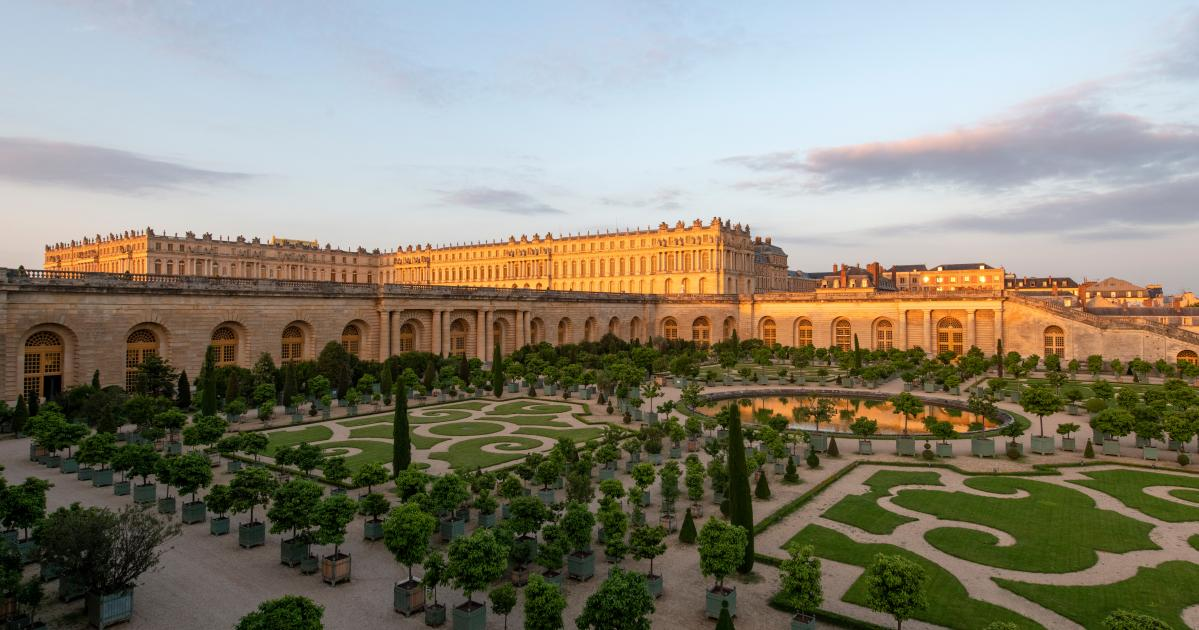How does the presence of the fountain enhance the overall aesthetic of the palace gardens? The fountain is the centerpiece of the palace gardens, enhancing their aesthetic with its dynamic presence. Its cascading waters add a sense of movement and life to the otherwise still and meticulously arranged greenery. The sound of the flowing water provides a calming ambiance, while the reflections of light on the water's surface create a mesmerizing effect. The fountain's ornate design complements the geometric precision of the garden layouts, tying together the natural beauty and human artistry in a harmonious blend. This focal point draws the eye and deepens the sense of awe and tranquility, enriching the overall experience of the gardens. 